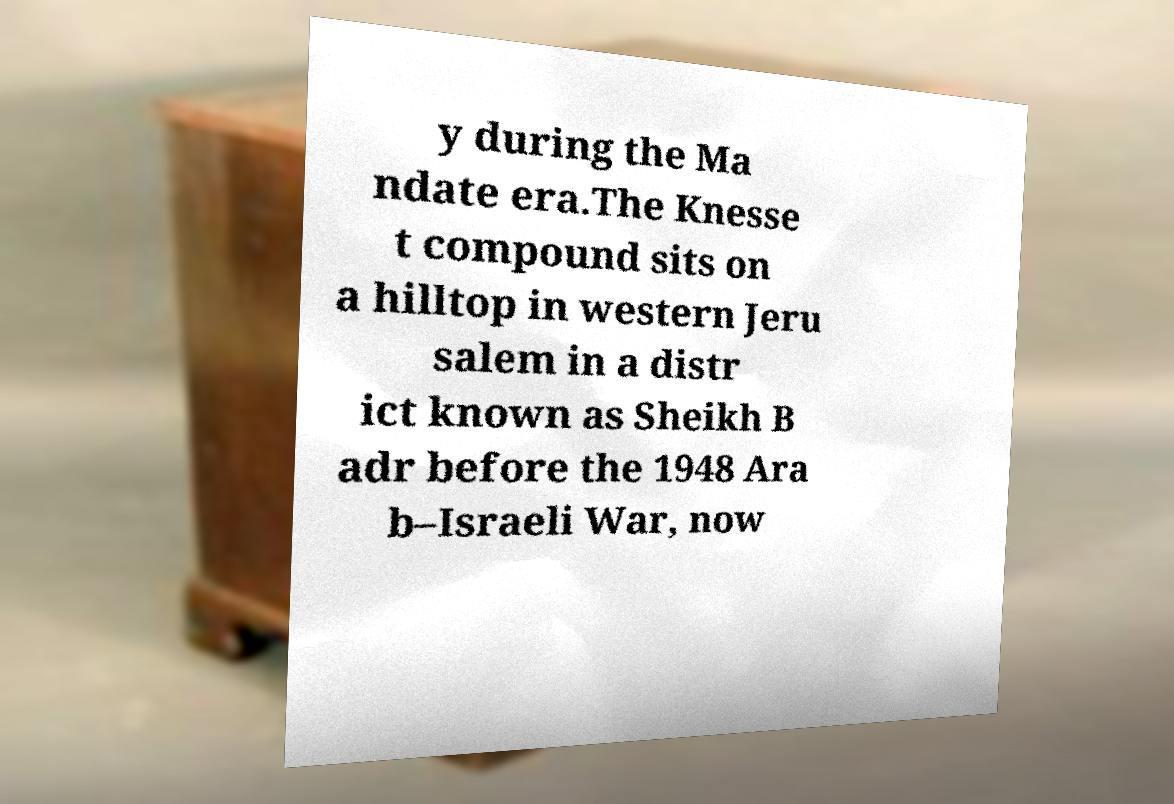Can you accurately transcribe the text from the provided image for me? y during the Ma ndate era.The Knesse t compound sits on a hilltop in western Jeru salem in a distr ict known as Sheikh B adr before the 1948 Ara b–Israeli War, now 